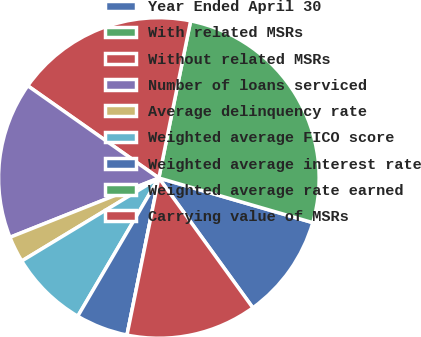Convert chart to OTSL. <chart><loc_0><loc_0><loc_500><loc_500><pie_chart><fcel>Year Ended April 30<fcel>With related MSRs<fcel>Without related MSRs<fcel>Number of loans serviced<fcel>Average delinquency rate<fcel>Weighted average FICO score<fcel>Weighted average interest rate<fcel>Weighted average rate earned<fcel>Carrying value of MSRs<nl><fcel>10.53%<fcel>26.32%<fcel>18.42%<fcel>15.79%<fcel>2.63%<fcel>7.89%<fcel>5.26%<fcel>0.0%<fcel>13.16%<nl></chart> 